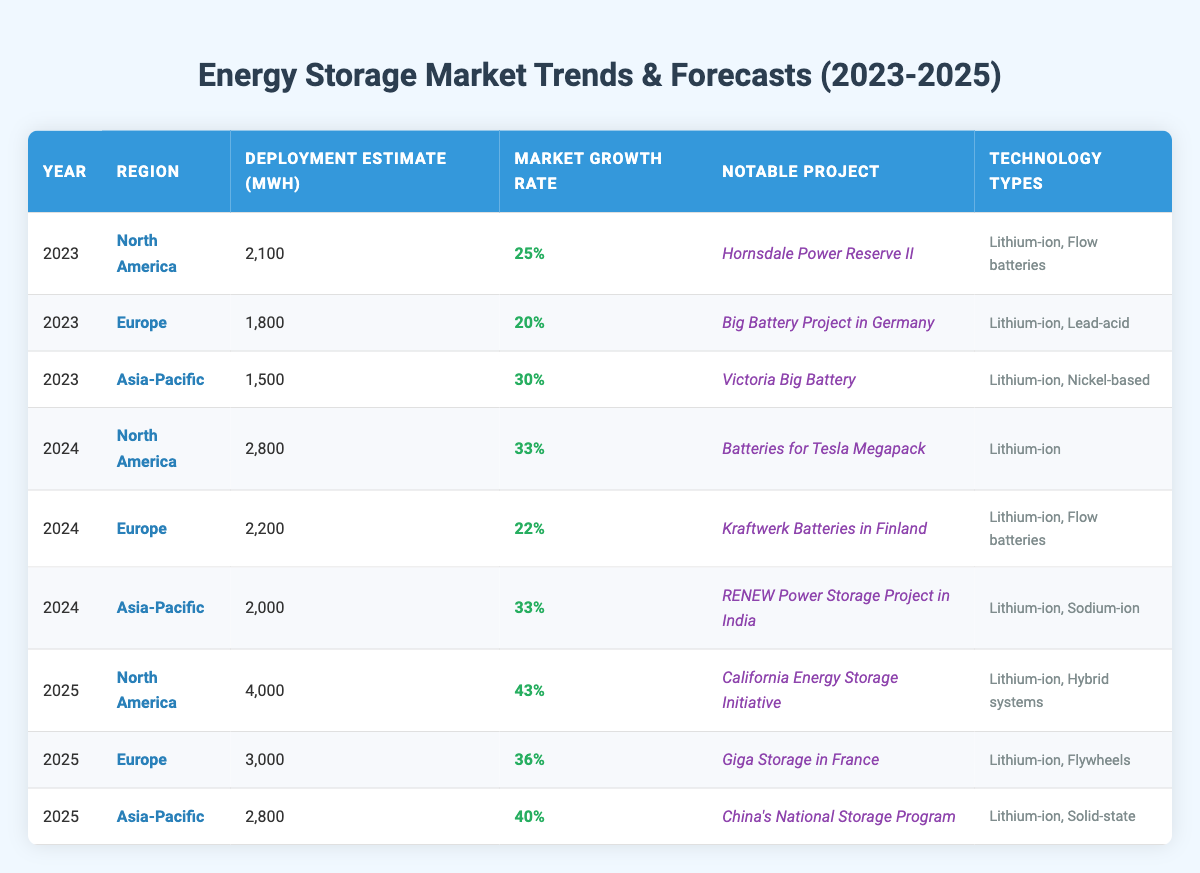What is the deployment estimate in North America for the year 2024? In the table, for the year 2024, the deployment estimate in North America is listed under the respective row, which shows a value of 2800 MWh.
Answer: 2800 MWh Which region shows the highest market growth rate in 2025? To find the region with the highest market growth rate in 2025, we look at the growth rate values for all three regions in that year: North America (43%), Europe (36%), and Asia-Pacific (40%). The highest value is from North America, at 43%.
Answer: North America What is the average deployment estimate across all regions for the year 2023? For 2023, the deployment estimates are: North America (2100 MWh), Europe (1800 MWh), and Asia-Pacific (1500 MWh). Summing these: 2100 + 1800 + 1500 = 5400 MWh. Dividing by 3 gives an average of 5400/3 = 1800 MWh.
Answer: 1800 MWh Is the notable project in Europe for 2024 related to flow batteries? The notable project in Europe for 2024 is listed as the "Kraftwerk Batteries in Finland," which includes technology types of Lithium-ion and Flow batteries. Therefore, it is related to flow batteries.
Answer: Yes What is the total deployment estimate for Asia-Pacific in 2024 and 2025? To find the total deployment estimate for Asia-Pacific in both years, we take the values: 2000 MWh for 2024 and 2800 MWh for 2025. Summing these: 2000 + 2800 = 4800 MWh.
Answer: 4800 MWh Which year has the lowest market growth rate among all regions? We need to compare the market growth rates provided for each year across all regions. For 2023, the rates are 25% (North America), 20% (Europe), and 30% (Asia-Pacific). For 2024, they are 33% (North America), 22% (Europe), and 33% (Asia-Pacific). For 2025, the rates are 43% (North America), 36% (Europe), and 40% (Asia-Pacific). The lowest rate overall is 20% in Europe for the year 2023.
Answer: 20% What technology type is common across all regions in 2025? By examining the technology types for all regions in 2025, we find: North America has Lithium-ion and Hybrid systems, Europe has Lithium-ion and Flywheels, and Asia-Pacific has Lithium-ion and Solid-state. The common technology type across them is Lithium-ion.
Answer: Lithium-ion What is the increase in deployment estimate from 2023 to 2025 for North America? For North America, the deployment estimates are 2100 MWh in 2023 and 4000 MWh in 2025. The increase is calculated by subtracting the 2023 value from the 2025 value: 4000 - 2100 = 1900 MWh.
Answer: 1900 MWh Which notable project in 2023 has the lowest deployment estimate? The notable projects for 2023 and their respective deployment estimates are: "Hornsdale Power Reserve II" (2100 MWh for North America), "Big Battery Project in Germany" (1800 MWh for Europe), and "Victoria Big Battery" (1500 MWh for Asia-Pacific). The lowest deployment estimate is from the project in Asia-Pacific with 1500 MWh.
Answer: Victoria Big Battery In which year does Europe have the highest deployment estimate? Reviewing the values, Europe has: 1800 MWh in 2023, 2200 MWh in 2024, and 3000 MWh in 2025. The highest deployment estimate for Europe is 3000 MWh in 2025.
Answer: 2025 